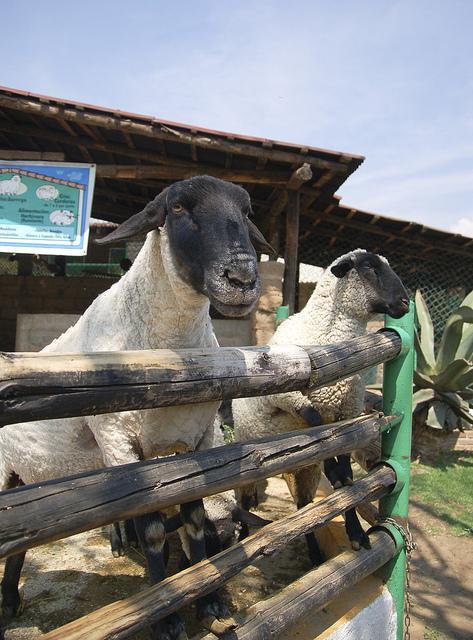How many sheep are standing up against the fence?
Give a very brief answer. 2. How many potted plants are there?
Give a very brief answer. 1. How many sheep can be seen?
Give a very brief answer. 2. 